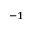<formula> <loc_0><loc_0><loc_500><loc_500>^ { - 1 }</formula> 